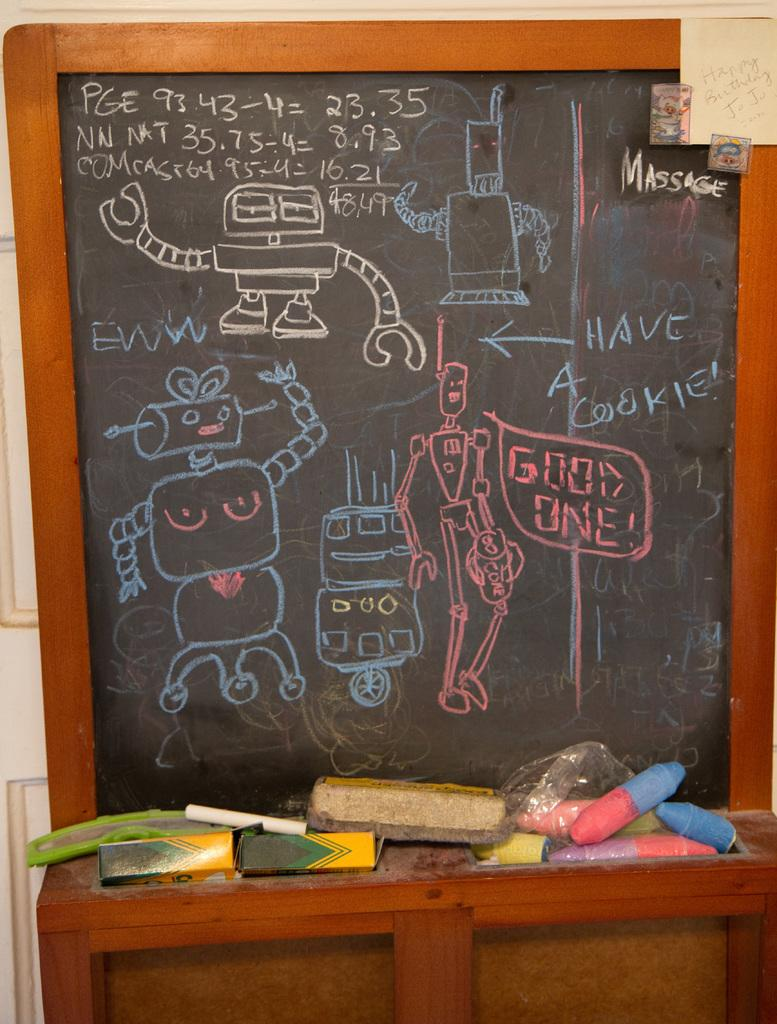<image>
Offer a succinct explanation of the picture presented. chalkboard with drawings of robots saying such things as have a cookie, good one, and eww 